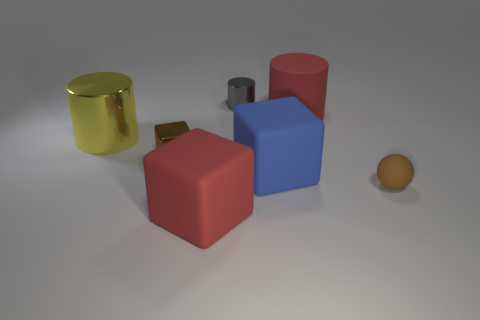What number of things are gray metallic cubes or red objects that are in front of the small rubber sphere?
Your answer should be very brief. 1. What is the size of the thing that is both behind the tiny brown metal thing and left of the small gray object?
Provide a succinct answer. Large. Are there more red things on the left side of the small shiny cylinder than small brown metallic objects to the right of the small sphere?
Keep it short and to the point. Yes. Does the gray metal object have the same shape as the large red object that is to the right of the gray shiny cylinder?
Provide a succinct answer. Yes. What number of other things are the same shape as the brown metallic thing?
Provide a succinct answer. 2. What is the color of the block that is both behind the brown matte sphere and left of the blue matte object?
Offer a very short reply. Brown. What color is the rubber cylinder?
Your answer should be very brief. Red. Is the small brown block made of the same material as the block in front of the tiny rubber ball?
Your answer should be compact. No. What is the shape of the tiny brown object that is the same material as the blue thing?
Provide a short and direct response. Sphere. The cylinder that is the same size as the shiny block is what color?
Make the answer very short. Gray. 